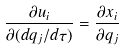<formula> <loc_0><loc_0><loc_500><loc_500>\frac { \partial { u } _ { i } } { \partial ( d q _ { j } / d \tau ) } = \frac { \partial { x } _ { i } } { \partial q _ { j } }</formula> 